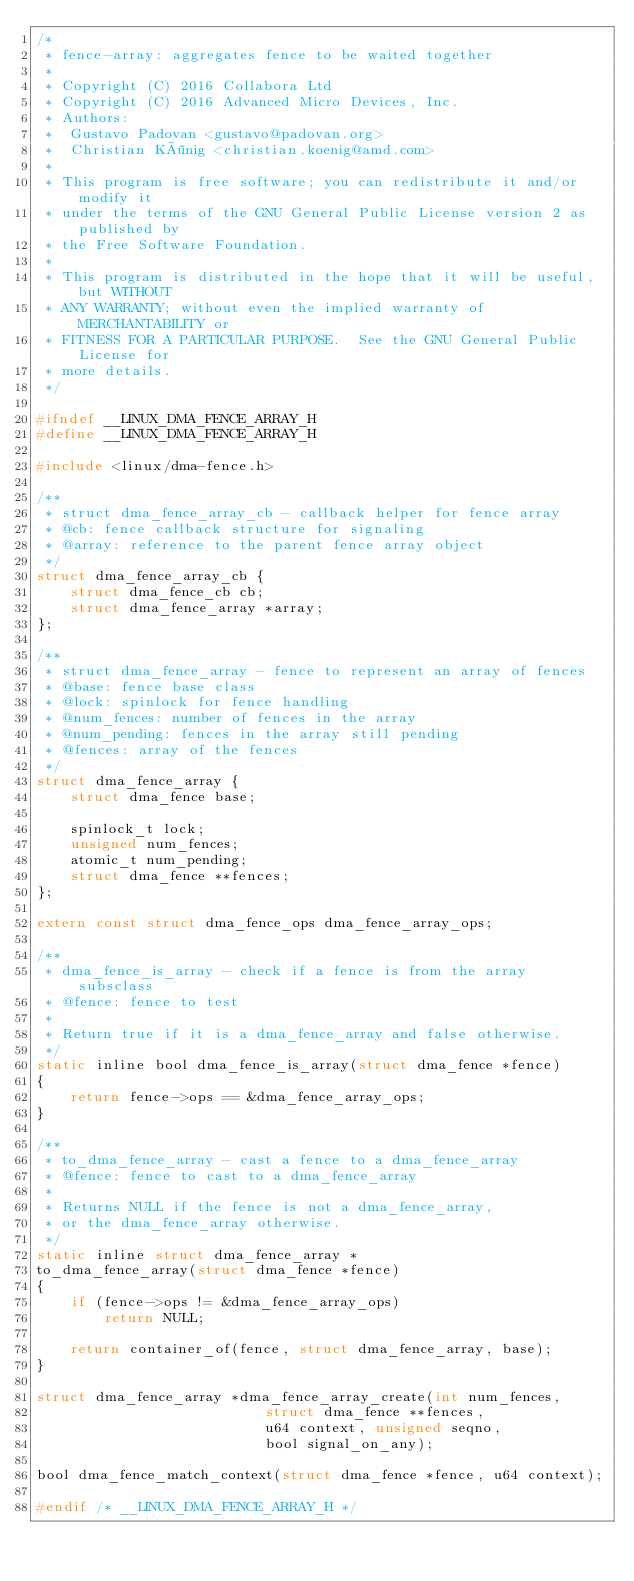Convert code to text. <code><loc_0><loc_0><loc_500><loc_500><_C_>/*
 * fence-array: aggregates fence to be waited together
 *
 * Copyright (C) 2016 Collabora Ltd
 * Copyright (C) 2016 Advanced Micro Devices, Inc.
 * Authors:
 *	Gustavo Padovan <gustavo@padovan.org>
 *	Christian König <christian.koenig@amd.com>
 *
 * This program is free software; you can redistribute it and/or modify it
 * under the terms of the GNU General Public License version 2 as published by
 * the Free Software Foundation.
 *
 * This program is distributed in the hope that it will be useful, but WITHOUT
 * ANY WARRANTY; without even the implied warranty of MERCHANTABILITY or
 * FITNESS FOR A PARTICULAR PURPOSE.  See the GNU General Public License for
 * more details.
 */

#ifndef __LINUX_DMA_FENCE_ARRAY_H
#define __LINUX_DMA_FENCE_ARRAY_H

#include <linux/dma-fence.h>

/**
 * struct dma_fence_array_cb - callback helper for fence array
 * @cb: fence callback structure for signaling
 * @array: reference to the parent fence array object
 */
struct dma_fence_array_cb {
	struct dma_fence_cb cb;
	struct dma_fence_array *array;
};

/**
 * struct dma_fence_array - fence to represent an array of fences
 * @base: fence base class
 * @lock: spinlock for fence handling
 * @num_fences: number of fences in the array
 * @num_pending: fences in the array still pending
 * @fences: array of the fences
 */
struct dma_fence_array {
	struct dma_fence base;

	spinlock_t lock;
	unsigned num_fences;
	atomic_t num_pending;
	struct dma_fence **fences;
};

extern const struct dma_fence_ops dma_fence_array_ops;

/**
 * dma_fence_is_array - check if a fence is from the array subsclass
 * @fence: fence to test
 *
 * Return true if it is a dma_fence_array and false otherwise.
 */
static inline bool dma_fence_is_array(struct dma_fence *fence)
{
	return fence->ops == &dma_fence_array_ops;
}

/**
 * to_dma_fence_array - cast a fence to a dma_fence_array
 * @fence: fence to cast to a dma_fence_array
 *
 * Returns NULL if the fence is not a dma_fence_array,
 * or the dma_fence_array otherwise.
 */
static inline struct dma_fence_array *
to_dma_fence_array(struct dma_fence *fence)
{
	if (fence->ops != &dma_fence_array_ops)
		return NULL;

	return container_of(fence, struct dma_fence_array, base);
}

struct dma_fence_array *dma_fence_array_create(int num_fences,
					       struct dma_fence **fences,
					       u64 context, unsigned seqno,
					       bool signal_on_any);

bool dma_fence_match_context(struct dma_fence *fence, u64 context);

#endif /* __LINUX_DMA_FENCE_ARRAY_H */
</code> 